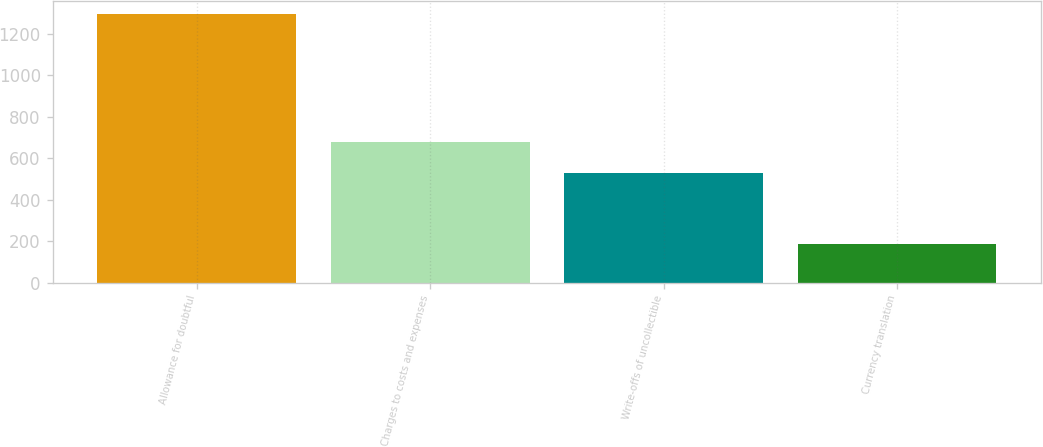<chart> <loc_0><loc_0><loc_500><loc_500><bar_chart><fcel>Allowance for doubtful<fcel>Charges to costs and expenses<fcel>Write-offs of uncollectible<fcel>Currency translation<nl><fcel>1294<fcel>678<fcel>527<fcel>184<nl></chart> 